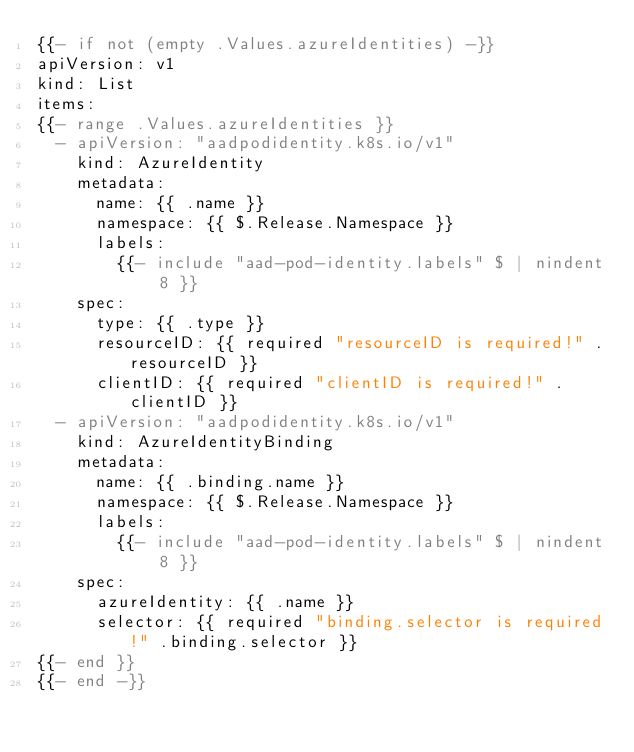<code> <loc_0><loc_0><loc_500><loc_500><_YAML_>{{- if not (empty .Values.azureIdentities) -}}
apiVersion: v1
kind: List
items:
{{- range .Values.azureIdentities }}
  - apiVersion: "aadpodidentity.k8s.io/v1"
    kind: AzureIdentity
    metadata:
      name: {{ .name }}
      namespace: {{ $.Release.Namespace }}
      labels:
        {{- include "aad-pod-identity.labels" $ | nindent 8 }}
    spec:
      type: {{ .type }}
      resourceID: {{ required "resourceID is required!" .resourceID }}
      clientID: {{ required "clientID is required!" .clientID }}
  - apiVersion: "aadpodidentity.k8s.io/v1"
    kind: AzureIdentityBinding
    metadata:
      name: {{ .binding.name }}
      namespace: {{ $.Release.Namespace }}
      labels:
        {{- include "aad-pod-identity.labels" $ | nindent 8 }}
    spec:
      azureIdentity: {{ .name }}
      selector: {{ required "binding.selector is required!" .binding.selector }}
{{- end }}
{{- end -}}
</code> 